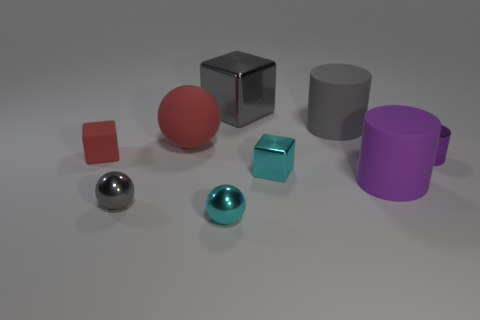Can you tell me which objects are closest to each other? The closest objects to each other are the small copper-colored cube and the matte turquoise cube, which are positioned adjacent to one another towards the center of the image. 